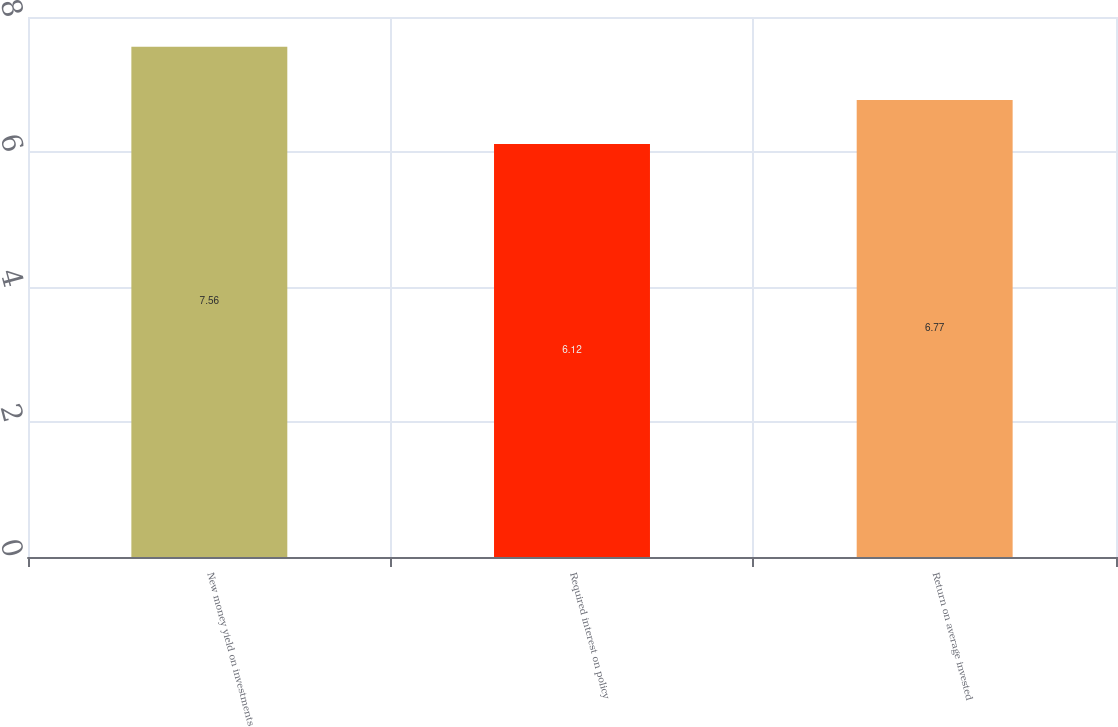<chart> <loc_0><loc_0><loc_500><loc_500><bar_chart><fcel>New money yield on investments<fcel>Required interest on policy<fcel>Return on average invested<nl><fcel>7.56<fcel>6.12<fcel>6.77<nl></chart> 